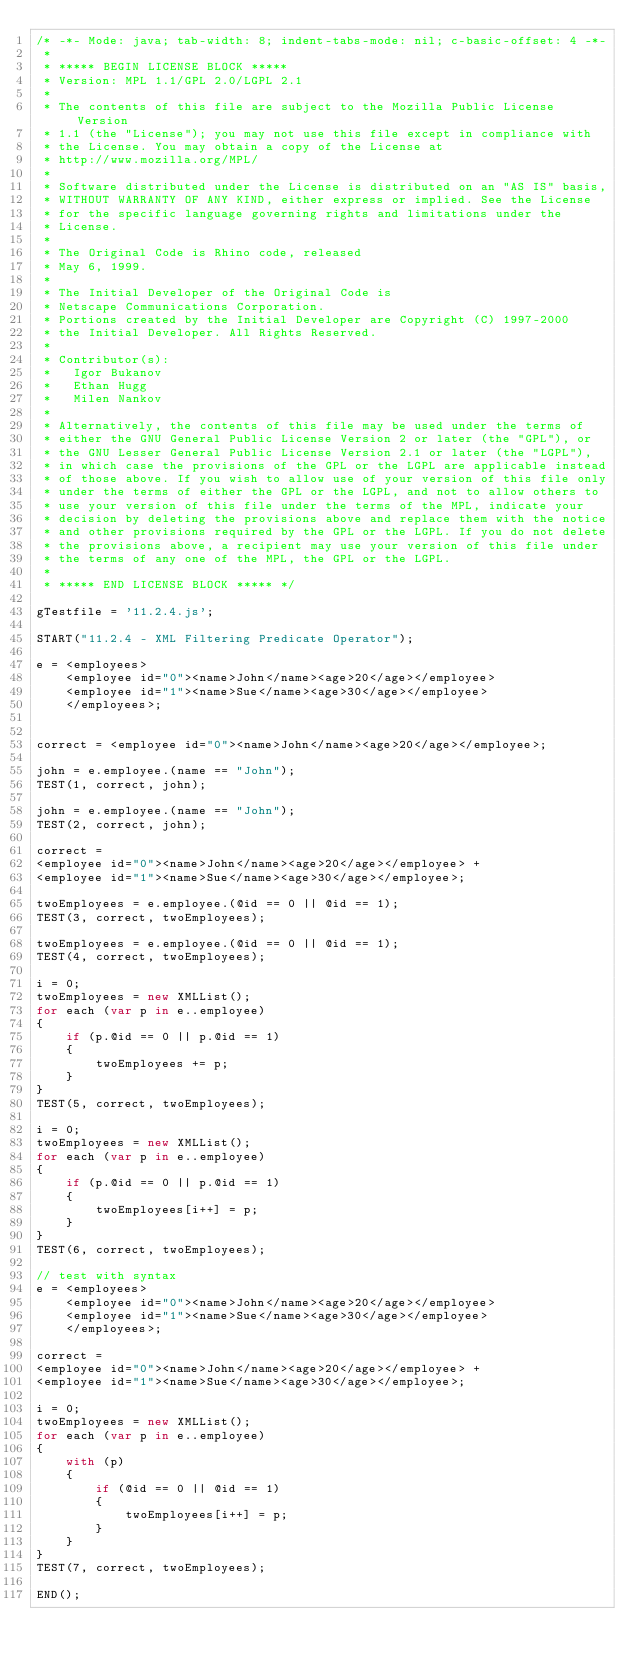<code> <loc_0><loc_0><loc_500><loc_500><_JavaScript_>/* -*- Mode: java; tab-width: 8; indent-tabs-mode: nil; c-basic-offset: 4 -*-
 *
 * ***** BEGIN LICENSE BLOCK *****
 * Version: MPL 1.1/GPL 2.0/LGPL 2.1
 *
 * The contents of this file are subject to the Mozilla Public License Version
 * 1.1 (the "License"); you may not use this file except in compliance with
 * the License. You may obtain a copy of the License at
 * http://www.mozilla.org/MPL/
 *
 * Software distributed under the License is distributed on an "AS IS" basis,
 * WITHOUT WARRANTY OF ANY KIND, either express or implied. See the License
 * for the specific language governing rights and limitations under the
 * License.
 *
 * The Original Code is Rhino code, released
 * May 6, 1999.
 *
 * The Initial Developer of the Original Code is
 * Netscape Communications Corporation.
 * Portions created by the Initial Developer are Copyright (C) 1997-2000
 * the Initial Developer. All Rights Reserved.
 *
 * Contributor(s):
 *   Igor Bukanov
 *   Ethan Hugg
 *   Milen Nankov
 *
 * Alternatively, the contents of this file may be used under the terms of
 * either the GNU General Public License Version 2 or later (the "GPL"), or
 * the GNU Lesser General Public License Version 2.1 or later (the "LGPL"),
 * in which case the provisions of the GPL or the LGPL are applicable instead
 * of those above. If you wish to allow use of your version of this file only
 * under the terms of either the GPL or the LGPL, and not to allow others to
 * use your version of this file under the terms of the MPL, indicate your
 * decision by deleting the provisions above and replace them with the notice
 * and other provisions required by the GPL or the LGPL. If you do not delete
 * the provisions above, a recipient may use your version of this file under
 * the terms of any one of the MPL, the GPL or the LGPL.
 *
 * ***** END LICENSE BLOCK ***** */

gTestfile = '11.2.4.js';

START("11.2.4 - XML Filtering Predicate Operator");

e = <employees>
    <employee id="0"><name>John</name><age>20</age></employee>
    <employee id="1"><name>Sue</name><age>30</age></employee>
    </employees>;


correct = <employee id="0"><name>John</name><age>20</age></employee>;

john = e.employee.(name == "John");
TEST(1, correct, john);   

john = e.employee.(name == "John");
TEST(2, correct, john);   

correct =
<employee id="0"><name>John</name><age>20</age></employee> +
<employee id="1"><name>Sue</name><age>30</age></employee>;

twoEmployees = e.employee.(@id == 0 || @id == 1);
TEST(3, correct, twoEmployees);

twoEmployees = e.employee.(@id == 0 || @id == 1);
TEST(4, correct, twoEmployees);

i = 0;
twoEmployees = new XMLList();
for each (var p in e..employee)
{
    if (p.@id == 0 || p.@id == 1)
    {
        twoEmployees += p;
    }
}
TEST(5, correct, twoEmployees);

i = 0;
twoEmployees = new XMLList();
for each (var p in e..employee)
{
    if (p.@id == 0 || p.@id == 1)
    {
        twoEmployees[i++] = p;
    }
}
TEST(6, correct, twoEmployees);

// test with syntax
e = <employees>
    <employee id="0"><name>John</name><age>20</age></employee>
    <employee id="1"><name>Sue</name><age>30</age></employee>
    </employees>;

correct =
<employee id="0"><name>John</name><age>20</age></employee> +
<employee id="1"><name>Sue</name><age>30</age></employee>;

i = 0;
twoEmployees = new XMLList();
for each (var p in e..employee)
{
    with (p)
    {
        if (@id == 0 || @id == 1)
        {
            twoEmployees[i++] = p;
        }
    }
}
TEST(7, correct, twoEmployees);

END();
</code> 